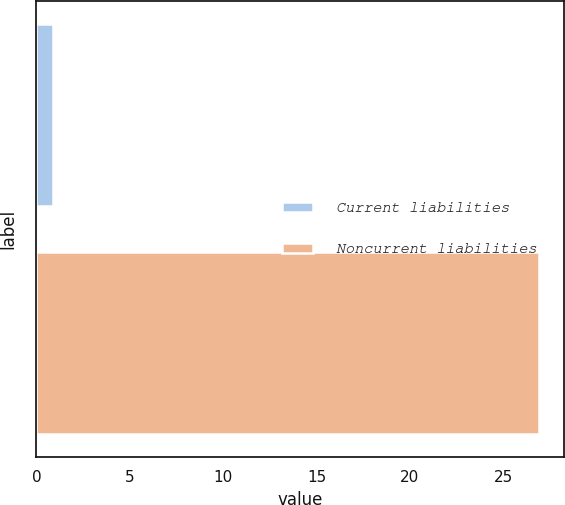Convert chart. <chart><loc_0><loc_0><loc_500><loc_500><bar_chart><fcel>Current liabilities<fcel>Noncurrent liabilities<nl><fcel>0.9<fcel>26.9<nl></chart> 